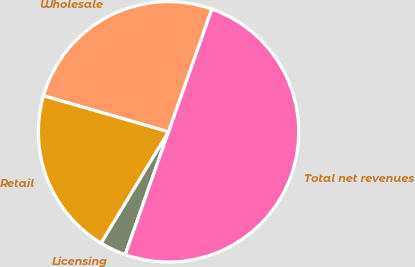<chart> <loc_0><loc_0><loc_500><loc_500><pie_chart><fcel>Wholesale<fcel>Retail<fcel>Licensing<fcel>Total net revenues<nl><fcel>25.93%<fcel>20.8%<fcel>3.27%<fcel>50.0%<nl></chart> 